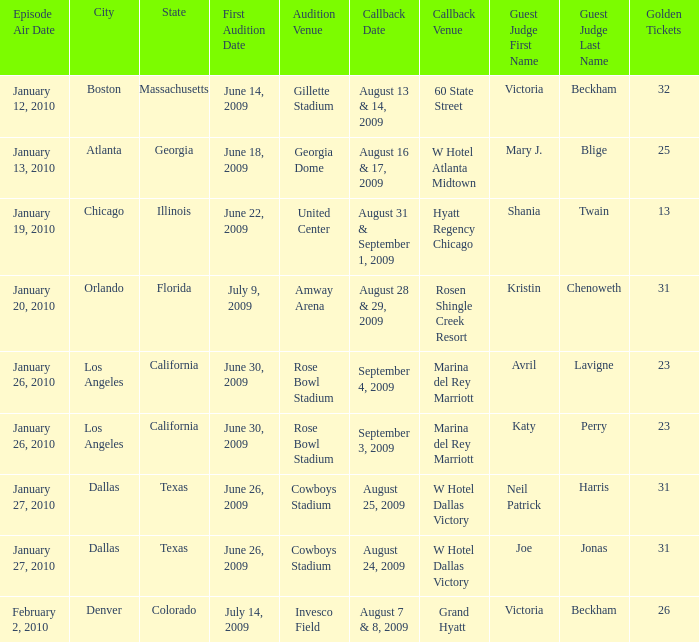Name the golden ticket for invesco field 26.0. 